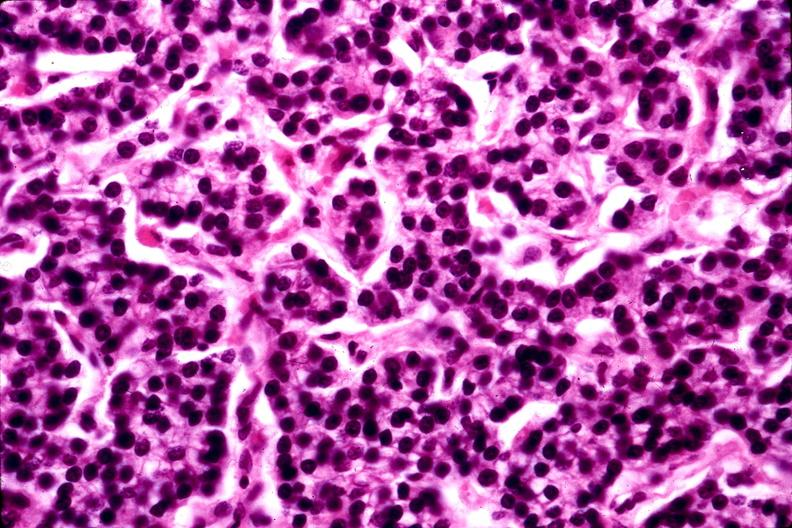does this image show parathyroid adenoma?
Answer the question using a single word or phrase. Yes 